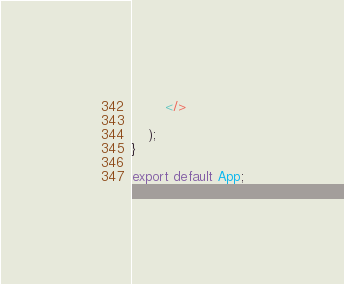<code> <loc_0><loc_0><loc_500><loc_500><_JavaScript_>        </>
        
    );
}

export default App;
</code> 